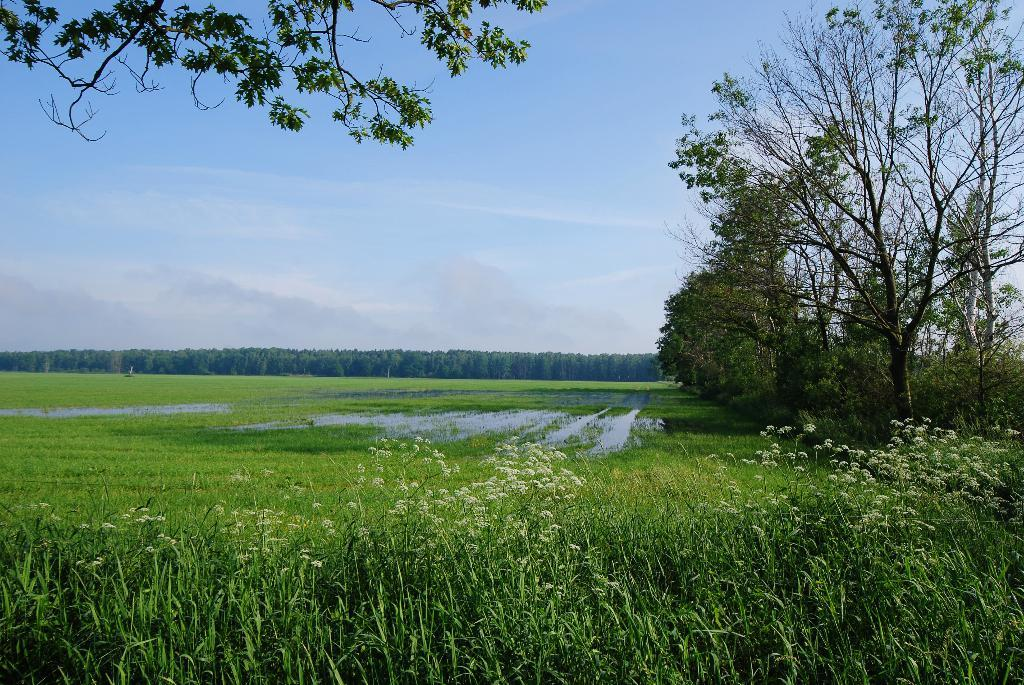What type of landscape is depicted on the right side of the image? There is a field on the right side of the image. What can be seen in the background of the field? There are trees in the background of the image. What is visible above the field and trees? The sky is visible in the image. Where is the basketball hoop located in the image? There is no basketball hoop present in the image. What type of lumber is being used to construct the field in the image? There is no construction or lumber visible in the image; it is a field with trees in the background and the sky above. 